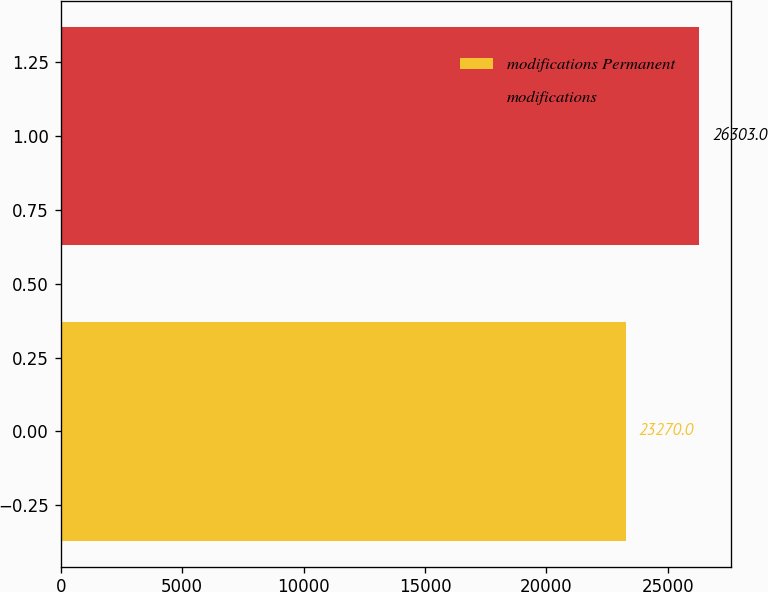Convert chart. <chart><loc_0><loc_0><loc_500><loc_500><bar_chart><fcel>modifications Permanent<fcel>modifications<nl><fcel>23270<fcel>26303<nl></chart> 